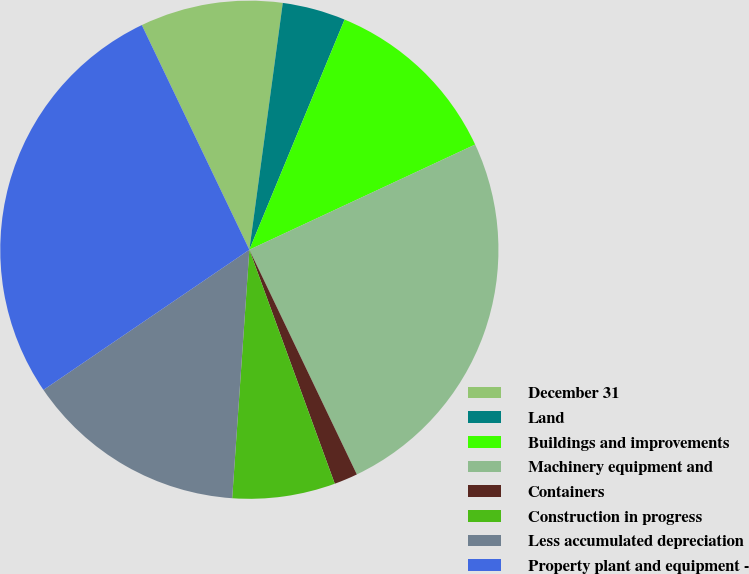Convert chart. <chart><loc_0><loc_0><loc_500><loc_500><pie_chart><fcel>December 31<fcel>Land<fcel>Buildings and improvements<fcel>Machinery equipment and<fcel>Containers<fcel>Construction in progress<fcel>Less accumulated depreciation<fcel>Property plant and equipment -<nl><fcel>9.25%<fcel>4.1%<fcel>11.82%<fcel>24.84%<fcel>1.53%<fcel>6.67%<fcel>14.39%<fcel>27.41%<nl></chart> 